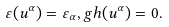Convert formula to latex. <formula><loc_0><loc_0><loc_500><loc_500>\varepsilon ( u ^ { \alpha } ) = \varepsilon _ { \alpha } , g h ( u ^ { \alpha } ) = 0 .</formula> 